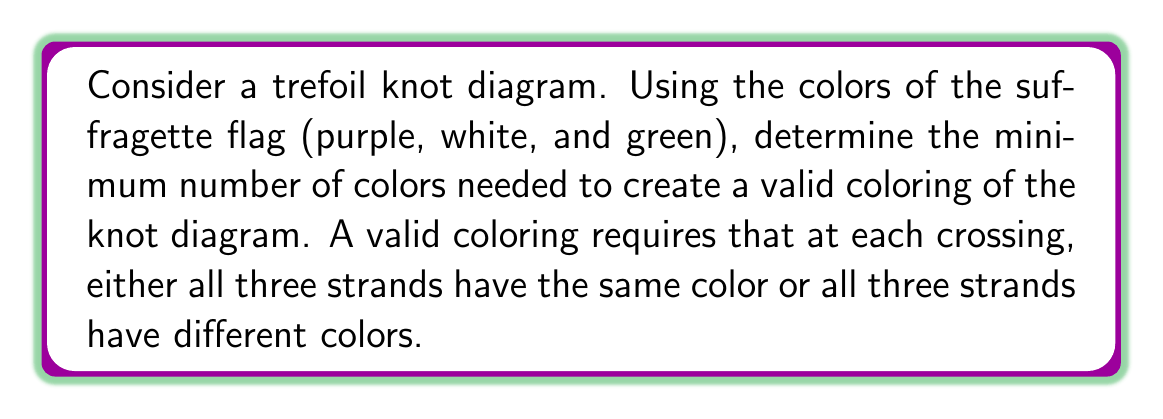Solve this math problem. Let's approach this step-by-step:

1) First, recall that the suffragette flag colors are purple, white, and green. We'll use these for our coloring.

2) A trefoil knot has three crossings. Let's label the arcs of the knot $a$, $b$, and $c$.

3) At each crossing, we have two options for a valid coloring:
   - All three strands have the same color
   - All three strands have different colors

4) Let's start by trying to color the knot with just one color. If we use only one color, all strands at all crossings will have the same color. This satisfies our coloring rule, but we need to check if it's the minimum.

5) Now, let's try using two colors. Assign color 1 to arc $a$. At the first crossing, we must use color 2 for arc $b$ to avoid having all strands the same color. Following this logic around the knot, we find that we need a third color for arc $c$.

6) This can be expressed mathematically as:

   $$\begin{cases}
   a \neq b \\
   b \neq c \\
   c \neq a
   \end{cases}$$

7) This system of inequalities cannot be satisfied with only two colors. We need at least three colors to create a valid coloring.

8) Fortunately, we have exactly three colors from the suffragette flag, which is sufficient to create a valid coloring of the trefoil knot.

Therefore, the minimum number of colors needed is 3, which coincides with the number of colors in the suffragette flag.
Answer: 3 colors 